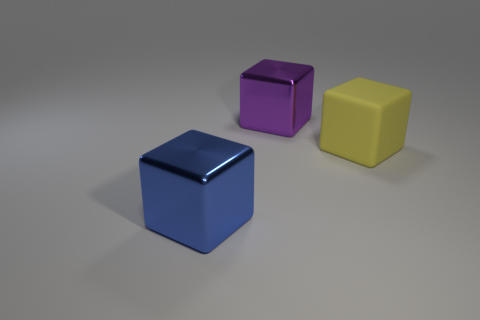The thing that is left of the purple shiny block is what color? The object to the left of the purple block in the image is a blue block with a reflective surface that catches the light, creating highlights and subtle shades on its surface. 